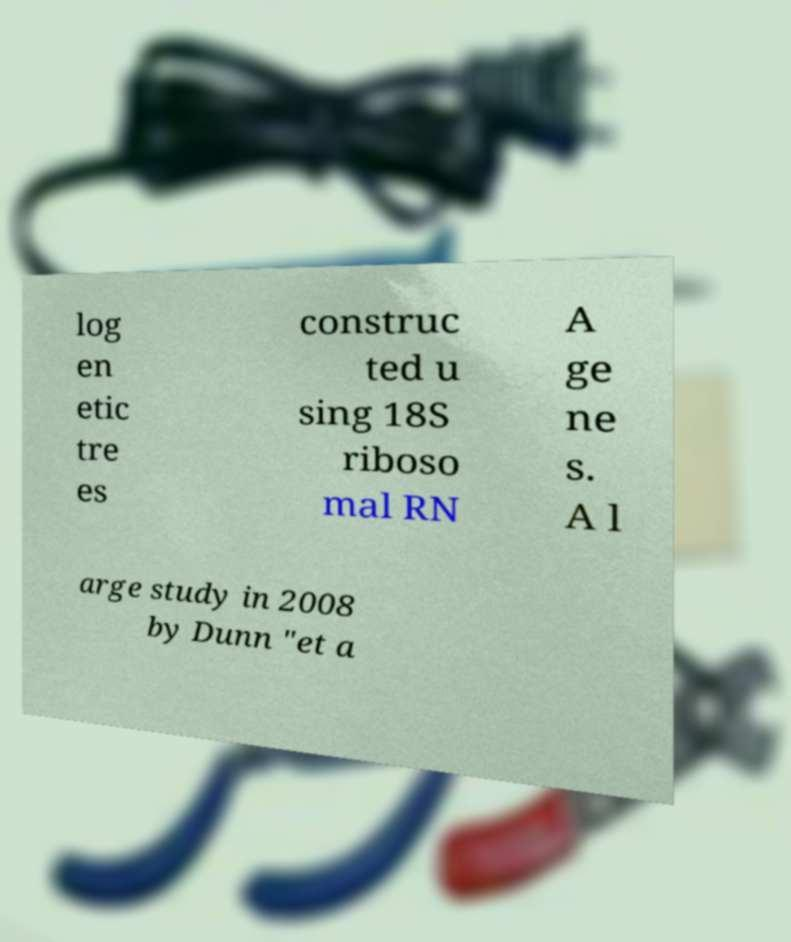Can you read and provide the text displayed in the image?This photo seems to have some interesting text. Can you extract and type it out for me? log en etic tre es construc ted u sing 18S riboso mal RN A ge ne s. A l arge study in 2008 by Dunn "et a 